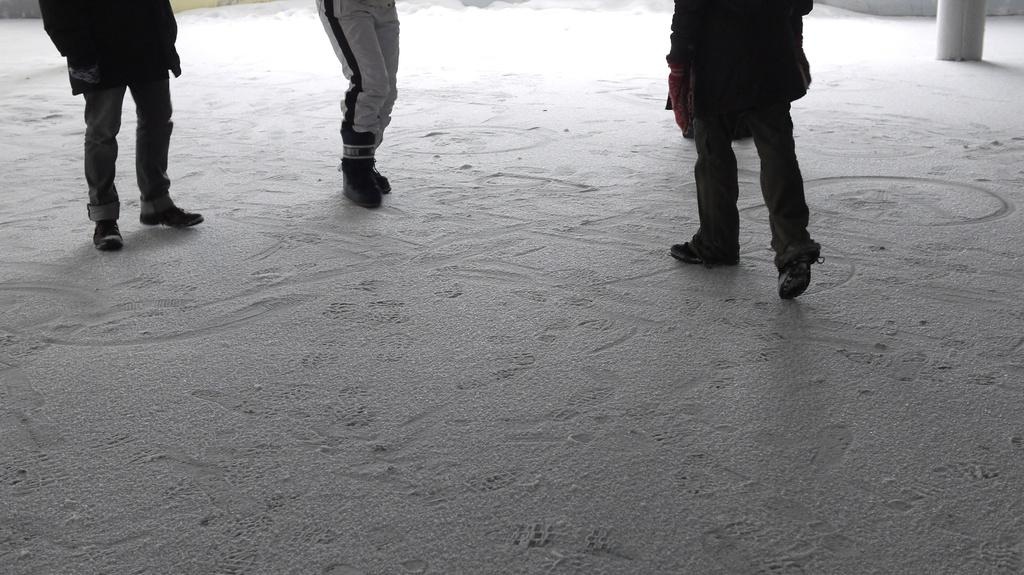What can be seen at the bottom of the image? There is a floor visible in the image. What else is present in the image besides the floor? There are legs of people visible in the image. What can be seen on the right side of the image? There is an object on the right side of the image. How many quinces are being adjusted by the people in the image? There are no quinces present in the image, and no adjustments are being made. What type of step is visible in the image? There is no step visible in the image. 